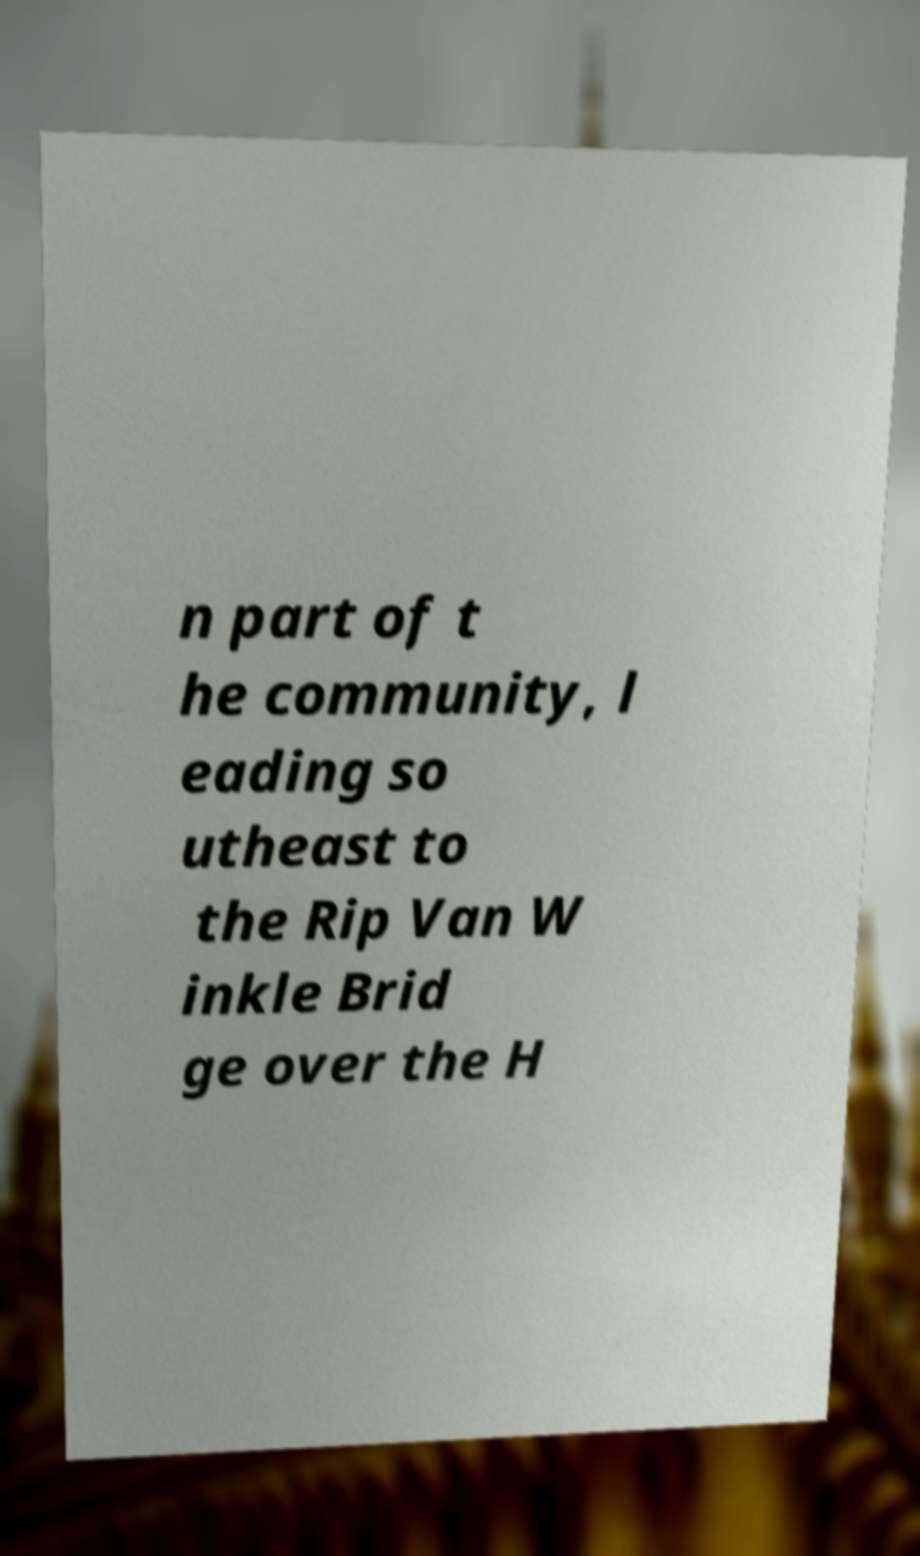What messages or text are displayed in this image? I need them in a readable, typed format. n part of t he community, l eading so utheast to the Rip Van W inkle Brid ge over the H 